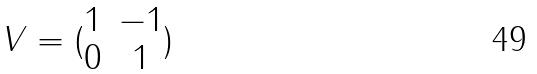Convert formula to latex. <formula><loc_0><loc_0><loc_500><loc_500>V = ( \begin{matrix} 1 & - 1 \\ 0 & 1 \end{matrix} )</formula> 